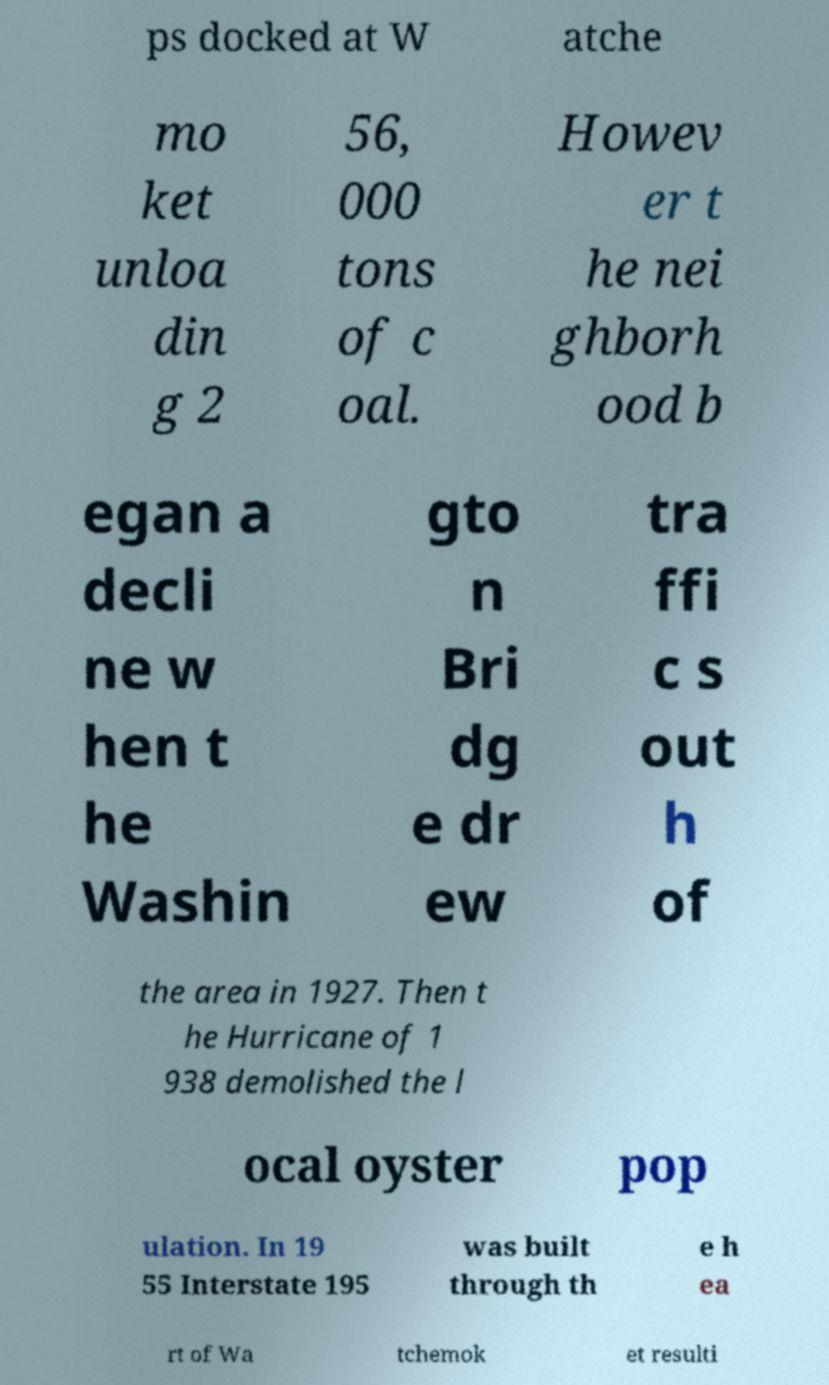There's text embedded in this image that I need extracted. Can you transcribe it verbatim? ps docked at W atche mo ket unloa din g 2 56, 000 tons of c oal. Howev er t he nei ghborh ood b egan a decli ne w hen t he Washin gto n Bri dg e dr ew tra ffi c s out h of the area in 1927. Then t he Hurricane of 1 938 demolished the l ocal oyster pop ulation. In 19 55 Interstate 195 was built through th e h ea rt of Wa tchemok et resulti 